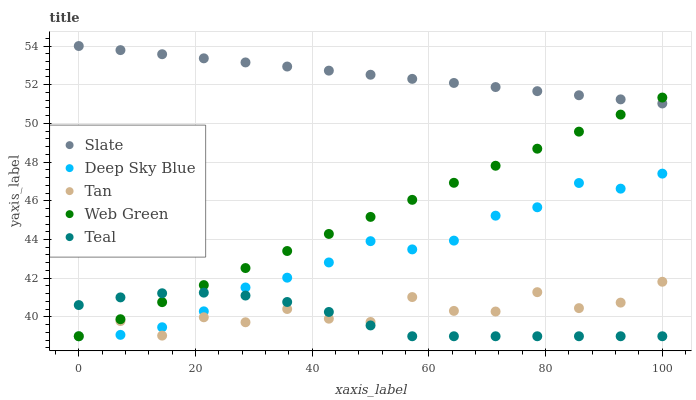Does Teal have the minimum area under the curve?
Answer yes or no. Yes. Does Slate have the maximum area under the curve?
Answer yes or no. Yes. Does Web Green have the minimum area under the curve?
Answer yes or no. No. Does Web Green have the maximum area under the curve?
Answer yes or no. No. Is Slate the smoothest?
Answer yes or no. Yes. Is Tan the roughest?
Answer yes or no. Yes. Is Web Green the smoothest?
Answer yes or no. No. Is Web Green the roughest?
Answer yes or no. No. Does Teal have the lowest value?
Answer yes or no. Yes. Does Slate have the lowest value?
Answer yes or no. No. Does Slate have the highest value?
Answer yes or no. Yes. Does Web Green have the highest value?
Answer yes or no. No. Is Deep Sky Blue less than Slate?
Answer yes or no. Yes. Is Slate greater than Tan?
Answer yes or no. Yes. Does Deep Sky Blue intersect Tan?
Answer yes or no. Yes. Is Deep Sky Blue less than Tan?
Answer yes or no. No. Is Deep Sky Blue greater than Tan?
Answer yes or no. No. Does Deep Sky Blue intersect Slate?
Answer yes or no. No. 